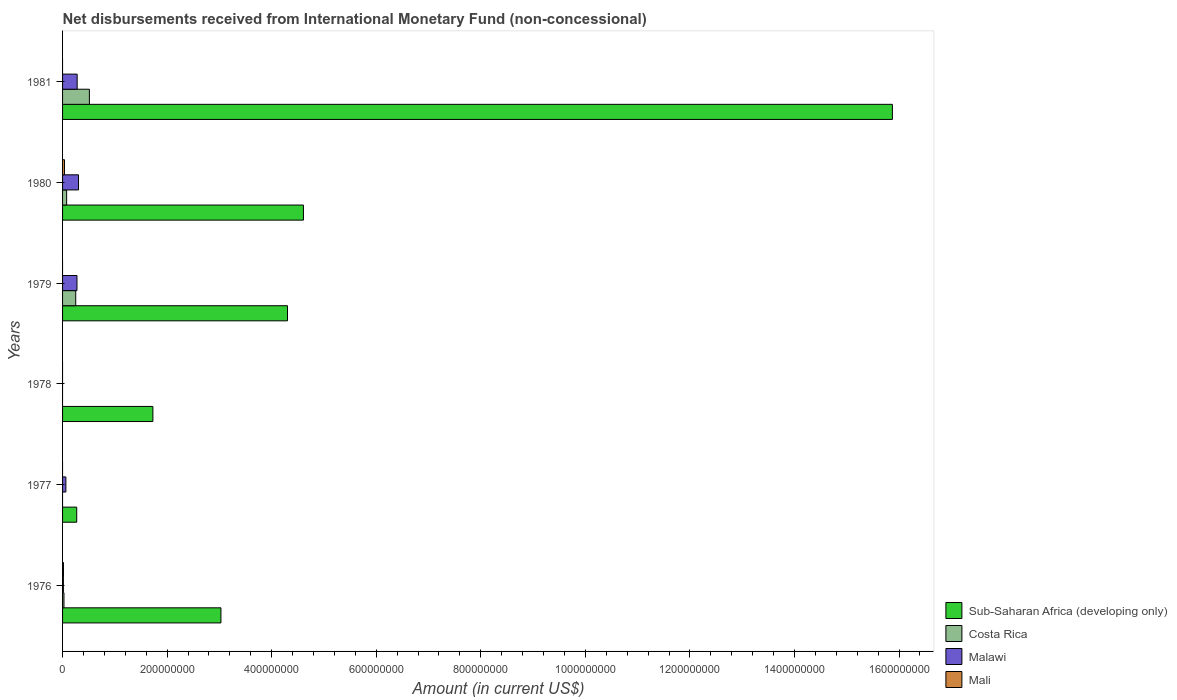How many different coloured bars are there?
Your answer should be very brief. 4. Are the number of bars per tick equal to the number of legend labels?
Offer a terse response. No. What is the label of the 5th group of bars from the top?
Make the answer very short. 1977. In how many cases, is the number of bars for a given year not equal to the number of legend labels?
Your answer should be compact. 4. Across all years, what is the maximum amount of disbursements received from International Monetary Fund in Malawi?
Provide a succinct answer. 3.05e+07. In which year was the amount of disbursements received from International Monetary Fund in Sub-Saharan Africa (developing only) maximum?
Make the answer very short. 1981. What is the total amount of disbursements received from International Monetary Fund in Costa Rica in the graph?
Keep it short and to the point. 8.70e+07. What is the difference between the amount of disbursements received from International Monetary Fund in Costa Rica in 1979 and that in 1981?
Make the answer very short. -2.61e+07. What is the difference between the amount of disbursements received from International Monetary Fund in Mali in 1980 and the amount of disbursements received from International Monetary Fund in Sub-Saharan Africa (developing only) in 1979?
Provide a succinct answer. -4.27e+08. What is the average amount of disbursements received from International Monetary Fund in Costa Rica per year?
Give a very brief answer. 1.45e+07. In the year 1980, what is the difference between the amount of disbursements received from International Monetary Fund in Malawi and amount of disbursements received from International Monetary Fund in Costa Rica?
Your response must be concise. 2.27e+07. In how many years, is the amount of disbursements received from International Monetary Fund in Costa Rica greater than 120000000 US$?
Provide a succinct answer. 0. What is the ratio of the amount of disbursements received from International Monetary Fund in Malawi in 1977 to that in 1981?
Your answer should be compact. 0.23. Is the amount of disbursements received from International Monetary Fund in Costa Rica in 1976 less than that in 1980?
Provide a short and direct response. Yes. What is the difference between the highest and the second highest amount of disbursements received from International Monetary Fund in Malawi?
Keep it short and to the point. 2.60e+06. What is the difference between the highest and the lowest amount of disbursements received from International Monetary Fund in Sub-Saharan Africa (developing only)?
Your response must be concise. 1.56e+09. Is the sum of the amount of disbursements received from International Monetary Fund in Costa Rica in 1976 and 1981 greater than the maximum amount of disbursements received from International Monetary Fund in Mali across all years?
Keep it short and to the point. Yes. Are all the bars in the graph horizontal?
Your answer should be very brief. Yes. How many years are there in the graph?
Provide a short and direct response. 6. Does the graph contain grids?
Ensure brevity in your answer.  No. Where does the legend appear in the graph?
Your response must be concise. Bottom right. How many legend labels are there?
Offer a very short reply. 4. What is the title of the graph?
Make the answer very short. Net disbursements received from International Monetary Fund (non-concessional). What is the Amount (in current US$) in Sub-Saharan Africa (developing only) in 1976?
Offer a very short reply. 3.03e+08. What is the Amount (in current US$) in Costa Rica in 1976?
Offer a very short reply. 2.69e+06. What is the Amount (in current US$) in Malawi in 1976?
Offer a very short reply. 1.57e+06. What is the Amount (in current US$) of Mali in 1976?
Offer a terse response. 1.72e+06. What is the Amount (in current US$) of Sub-Saharan Africa (developing only) in 1977?
Your answer should be compact. 2.71e+07. What is the Amount (in current US$) of Malawi in 1977?
Your answer should be very brief. 6.34e+06. What is the Amount (in current US$) of Mali in 1977?
Provide a short and direct response. 0. What is the Amount (in current US$) of Sub-Saharan Africa (developing only) in 1978?
Provide a short and direct response. 1.73e+08. What is the Amount (in current US$) in Malawi in 1978?
Your answer should be compact. 0. What is the Amount (in current US$) in Mali in 1978?
Make the answer very short. 0. What is the Amount (in current US$) in Sub-Saharan Africa (developing only) in 1979?
Offer a very short reply. 4.30e+08. What is the Amount (in current US$) of Costa Rica in 1979?
Offer a terse response. 2.52e+07. What is the Amount (in current US$) in Malawi in 1979?
Your response must be concise. 2.75e+07. What is the Amount (in current US$) in Mali in 1979?
Your answer should be compact. 0. What is the Amount (in current US$) in Sub-Saharan Africa (developing only) in 1980?
Offer a terse response. 4.61e+08. What is the Amount (in current US$) of Costa Rica in 1980?
Ensure brevity in your answer.  7.80e+06. What is the Amount (in current US$) in Malawi in 1980?
Make the answer very short. 3.05e+07. What is the Amount (in current US$) of Mali in 1980?
Your response must be concise. 3.70e+06. What is the Amount (in current US$) of Sub-Saharan Africa (developing only) in 1981?
Provide a succinct answer. 1.59e+09. What is the Amount (in current US$) in Costa Rica in 1981?
Offer a terse response. 5.13e+07. What is the Amount (in current US$) of Malawi in 1981?
Give a very brief answer. 2.79e+07. Across all years, what is the maximum Amount (in current US$) in Sub-Saharan Africa (developing only)?
Offer a terse response. 1.59e+09. Across all years, what is the maximum Amount (in current US$) in Costa Rica?
Give a very brief answer. 5.13e+07. Across all years, what is the maximum Amount (in current US$) of Malawi?
Give a very brief answer. 3.05e+07. Across all years, what is the maximum Amount (in current US$) in Mali?
Offer a terse response. 3.70e+06. Across all years, what is the minimum Amount (in current US$) in Sub-Saharan Africa (developing only)?
Ensure brevity in your answer.  2.71e+07. Across all years, what is the minimum Amount (in current US$) in Costa Rica?
Your answer should be compact. 0. What is the total Amount (in current US$) of Sub-Saharan Africa (developing only) in the graph?
Give a very brief answer. 2.98e+09. What is the total Amount (in current US$) of Costa Rica in the graph?
Your answer should be very brief. 8.70e+07. What is the total Amount (in current US$) of Malawi in the graph?
Provide a succinct answer. 9.38e+07. What is the total Amount (in current US$) in Mali in the graph?
Offer a terse response. 5.42e+06. What is the difference between the Amount (in current US$) in Sub-Saharan Africa (developing only) in 1976 and that in 1977?
Make the answer very short. 2.76e+08. What is the difference between the Amount (in current US$) in Malawi in 1976 and that in 1977?
Offer a very short reply. -4.77e+06. What is the difference between the Amount (in current US$) in Sub-Saharan Africa (developing only) in 1976 and that in 1978?
Your answer should be compact. 1.30e+08. What is the difference between the Amount (in current US$) in Sub-Saharan Africa (developing only) in 1976 and that in 1979?
Keep it short and to the point. -1.27e+08. What is the difference between the Amount (in current US$) of Costa Rica in 1976 and that in 1979?
Your response must be concise. -2.25e+07. What is the difference between the Amount (in current US$) of Malawi in 1976 and that in 1979?
Ensure brevity in your answer.  -2.60e+07. What is the difference between the Amount (in current US$) of Sub-Saharan Africa (developing only) in 1976 and that in 1980?
Provide a succinct answer. -1.58e+08. What is the difference between the Amount (in current US$) in Costa Rica in 1976 and that in 1980?
Make the answer very short. -5.11e+06. What is the difference between the Amount (in current US$) in Malawi in 1976 and that in 1980?
Keep it short and to the point. -2.89e+07. What is the difference between the Amount (in current US$) in Mali in 1976 and that in 1980?
Keep it short and to the point. -1.98e+06. What is the difference between the Amount (in current US$) in Sub-Saharan Africa (developing only) in 1976 and that in 1981?
Your answer should be very brief. -1.28e+09. What is the difference between the Amount (in current US$) in Costa Rica in 1976 and that in 1981?
Provide a short and direct response. -4.86e+07. What is the difference between the Amount (in current US$) of Malawi in 1976 and that in 1981?
Your answer should be compact. -2.63e+07. What is the difference between the Amount (in current US$) of Sub-Saharan Africa (developing only) in 1977 and that in 1978?
Your answer should be compact. -1.46e+08. What is the difference between the Amount (in current US$) in Sub-Saharan Africa (developing only) in 1977 and that in 1979?
Offer a terse response. -4.03e+08. What is the difference between the Amount (in current US$) of Malawi in 1977 and that in 1979?
Provide a short and direct response. -2.12e+07. What is the difference between the Amount (in current US$) of Sub-Saharan Africa (developing only) in 1977 and that in 1980?
Your response must be concise. -4.34e+08. What is the difference between the Amount (in current US$) of Malawi in 1977 and that in 1980?
Your response must be concise. -2.42e+07. What is the difference between the Amount (in current US$) of Sub-Saharan Africa (developing only) in 1977 and that in 1981?
Keep it short and to the point. -1.56e+09. What is the difference between the Amount (in current US$) of Malawi in 1977 and that in 1981?
Offer a terse response. -2.16e+07. What is the difference between the Amount (in current US$) of Sub-Saharan Africa (developing only) in 1978 and that in 1979?
Your answer should be compact. -2.57e+08. What is the difference between the Amount (in current US$) of Sub-Saharan Africa (developing only) in 1978 and that in 1980?
Keep it short and to the point. -2.88e+08. What is the difference between the Amount (in current US$) of Sub-Saharan Africa (developing only) in 1978 and that in 1981?
Ensure brevity in your answer.  -1.41e+09. What is the difference between the Amount (in current US$) of Sub-Saharan Africa (developing only) in 1979 and that in 1980?
Ensure brevity in your answer.  -3.05e+07. What is the difference between the Amount (in current US$) in Costa Rica in 1979 and that in 1980?
Provide a succinct answer. 1.74e+07. What is the difference between the Amount (in current US$) of Malawi in 1979 and that in 1980?
Keep it short and to the point. -2.97e+06. What is the difference between the Amount (in current US$) of Sub-Saharan Africa (developing only) in 1979 and that in 1981?
Your response must be concise. -1.16e+09. What is the difference between the Amount (in current US$) in Costa Rica in 1979 and that in 1981?
Provide a succinct answer. -2.61e+07. What is the difference between the Amount (in current US$) of Malawi in 1979 and that in 1981?
Your answer should be very brief. -3.66e+05. What is the difference between the Amount (in current US$) of Sub-Saharan Africa (developing only) in 1980 and that in 1981?
Your answer should be very brief. -1.13e+09. What is the difference between the Amount (in current US$) in Costa Rica in 1980 and that in 1981?
Your answer should be compact. -4.35e+07. What is the difference between the Amount (in current US$) of Malawi in 1980 and that in 1981?
Keep it short and to the point. 2.60e+06. What is the difference between the Amount (in current US$) of Sub-Saharan Africa (developing only) in 1976 and the Amount (in current US$) of Malawi in 1977?
Your response must be concise. 2.97e+08. What is the difference between the Amount (in current US$) in Costa Rica in 1976 and the Amount (in current US$) in Malawi in 1977?
Your answer should be compact. -3.65e+06. What is the difference between the Amount (in current US$) of Sub-Saharan Africa (developing only) in 1976 and the Amount (in current US$) of Costa Rica in 1979?
Give a very brief answer. 2.78e+08. What is the difference between the Amount (in current US$) of Sub-Saharan Africa (developing only) in 1976 and the Amount (in current US$) of Malawi in 1979?
Provide a succinct answer. 2.75e+08. What is the difference between the Amount (in current US$) in Costa Rica in 1976 and the Amount (in current US$) in Malawi in 1979?
Give a very brief answer. -2.48e+07. What is the difference between the Amount (in current US$) in Sub-Saharan Africa (developing only) in 1976 and the Amount (in current US$) in Costa Rica in 1980?
Make the answer very short. 2.95e+08. What is the difference between the Amount (in current US$) in Sub-Saharan Africa (developing only) in 1976 and the Amount (in current US$) in Malawi in 1980?
Ensure brevity in your answer.  2.72e+08. What is the difference between the Amount (in current US$) of Sub-Saharan Africa (developing only) in 1976 and the Amount (in current US$) of Mali in 1980?
Keep it short and to the point. 2.99e+08. What is the difference between the Amount (in current US$) in Costa Rica in 1976 and the Amount (in current US$) in Malawi in 1980?
Your answer should be very brief. -2.78e+07. What is the difference between the Amount (in current US$) in Costa Rica in 1976 and the Amount (in current US$) in Mali in 1980?
Ensure brevity in your answer.  -1.01e+06. What is the difference between the Amount (in current US$) in Malawi in 1976 and the Amount (in current US$) in Mali in 1980?
Provide a short and direct response. -2.13e+06. What is the difference between the Amount (in current US$) in Sub-Saharan Africa (developing only) in 1976 and the Amount (in current US$) in Costa Rica in 1981?
Provide a short and direct response. 2.52e+08. What is the difference between the Amount (in current US$) of Sub-Saharan Africa (developing only) in 1976 and the Amount (in current US$) of Malawi in 1981?
Make the answer very short. 2.75e+08. What is the difference between the Amount (in current US$) of Costa Rica in 1976 and the Amount (in current US$) of Malawi in 1981?
Keep it short and to the point. -2.52e+07. What is the difference between the Amount (in current US$) in Sub-Saharan Africa (developing only) in 1977 and the Amount (in current US$) in Costa Rica in 1979?
Give a very brief answer. 1.89e+06. What is the difference between the Amount (in current US$) of Sub-Saharan Africa (developing only) in 1977 and the Amount (in current US$) of Malawi in 1979?
Offer a very short reply. -4.60e+05. What is the difference between the Amount (in current US$) of Sub-Saharan Africa (developing only) in 1977 and the Amount (in current US$) of Costa Rica in 1980?
Offer a very short reply. 1.93e+07. What is the difference between the Amount (in current US$) of Sub-Saharan Africa (developing only) in 1977 and the Amount (in current US$) of Malawi in 1980?
Give a very brief answer. -3.43e+06. What is the difference between the Amount (in current US$) of Sub-Saharan Africa (developing only) in 1977 and the Amount (in current US$) of Mali in 1980?
Provide a short and direct response. 2.34e+07. What is the difference between the Amount (in current US$) of Malawi in 1977 and the Amount (in current US$) of Mali in 1980?
Your answer should be very brief. 2.64e+06. What is the difference between the Amount (in current US$) of Sub-Saharan Africa (developing only) in 1977 and the Amount (in current US$) of Costa Rica in 1981?
Your answer should be compact. -2.42e+07. What is the difference between the Amount (in current US$) in Sub-Saharan Africa (developing only) in 1977 and the Amount (in current US$) in Malawi in 1981?
Ensure brevity in your answer.  -8.26e+05. What is the difference between the Amount (in current US$) of Sub-Saharan Africa (developing only) in 1978 and the Amount (in current US$) of Costa Rica in 1979?
Your answer should be very brief. 1.48e+08. What is the difference between the Amount (in current US$) of Sub-Saharan Africa (developing only) in 1978 and the Amount (in current US$) of Malawi in 1979?
Offer a terse response. 1.45e+08. What is the difference between the Amount (in current US$) in Sub-Saharan Africa (developing only) in 1978 and the Amount (in current US$) in Costa Rica in 1980?
Ensure brevity in your answer.  1.65e+08. What is the difference between the Amount (in current US$) in Sub-Saharan Africa (developing only) in 1978 and the Amount (in current US$) in Malawi in 1980?
Offer a very short reply. 1.42e+08. What is the difference between the Amount (in current US$) in Sub-Saharan Africa (developing only) in 1978 and the Amount (in current US$) in Mali in 1980?
Your response must be concise. 1.69e+08. What is the difference between the Amount (in current US$) of Sub-Saharan Africa (developing only) in 1978 and the Amount (in current US$) of Costa Rica in 1981?
Provide a short and direct response. 1.21e+08. What is the difference between the Amount (in current US$) of Sub-Saharan Africa (developing only) in 1978 and the Amount (in current US$) of Malawi in 1981?
Make the answer very short. 1.45e+08. What is the difference between the Amount (in current US$) in Sub-Saharan Africa (developing only) in 1979 and the Amount (in current US$) in Costa Rica in 1980?
Your answer should be compact. 4.22e+08. What is the difference between the Amount (in current US$) in Sub-Saharan Africa (developing only) in 1979 and the Amount (in current US$) in Malawi in 1980?
Make the answer very short. 4.00e+08. What is the difference between the Amount (in current US$) in Sub-Saharan Africa (developing only) in 1979 and the Amount (in current US$) in Mali in 1980?
Offer a terse response. 4.27e+08. What is the difference between the Amount (in current US$) of Costa Rica in 1979 and the Amount (in current US$) of Malawi in 1980?
Make the answer very short. -5.32e+06. What is the difference between the Amount (in current US$) of Costa Rica in 1979 and the Amount (in current US$) of Mali in 1980?
Keep it short and to the point. 2.15e+07. What is the difference between the Amount (in current US$) of Malawi in 1979 and the Amount (in current US$) of Mali in 1980?
Offer a terse response. 2.38e+07. What is the difference between the Amount (in current US$) in Sub-Saharan Africa (developing only) in 1979 and the Amount (in current US$) in Costa Rica in 1981?
Your answer should be compact. 3.79e+08. What is the difference between the Amount (in current US$) of Sub-Saharan Africa (developing only) in 1979 and the Amount (in current US$) of Malawi in 1981?
Offer a terse response. 4.02e+08. What is the difference between the Amount (in current US$) in Costa Rica in 1979 and the Amount (in current US$) in Malawi in 1981?
Offer a terse response. -2.72e+06. What is the difference between the Amount (in current US$) of Sub-Saharan Africa (developing only) in 1980 and the Amount (in current US$) of Costa Rica in 1981?
Ensure brevity in your answer.  4.09e+08. What is the difference between the Amount (in current US$) of Sub-Saharan Africa (developing only) in 1980 and the Amount (in current US$) of Malawi in 1981?
Provide a short and direct response. 4.33e+08. What is the difference between the Amount (in current US$) of Costa Rica in 1980 and the Amount (in current US$) of Malawi in 1981?
Offer a terse response. -2.01e+07. What is the average Amount (in current US$) in Sub-Saharan Africa (developing only) per year?
Keep it short and to the point. 4.97e+08. What is the average Amount (in current US$) in Costa Rica per year?
Keep it short and to the point. 1.45e+07. What is the average Amount (in current US$) in Malawi per year?
Your response must be concise. 1.56e+07. What is the average Amount (in current US$) in Mali per year?
Your response must be concise. 9.04e+05. In the year 1976, what is the difference between the Amount (in current US$) of Sub-Saharan Africa (developing only) and Amount (in current US$) of Costa Rica?
Provide a short and direct response. 3.00e+08. In the year 1976, what is the difference between the Amount (in current US$) in Sub-Saharan Africa (developing only) and Amount (in current US$) in Malawi?
Your response must be concise. 3.01e+08. In the year 1976, what is the difference between the Amount (in current US$) of Sub-Saharan Africa (developing only) and Amount (in current US$) of Mali?
Your answer should be compact. 3.01e+08. In the year 1976, what is the difference between the Amount (in current US$) of Costa Rica and Amount (in current US$) of Malawi?
Offer a terse response. 1.12e+06. In the year 1976, what is the difference between the Amount (in current US$) of Costa Rica and Amount (in current US$) of Mali?
Offer a terse response. 9.70e+05. In the year 1976, what is the difference between the Amount (in current US$) in Malawi and Amount (in current US$) in Mali?
Ensure brevity in your answer.  -1.51e+05. In the year 1977, what is the difference between the Amount (in current US$) in Sub-Saharan Africa (developing only) and Amount (in current US$) in Malawi?
Make the answer very short. 2.07e+07. In the year 1979, what is the difference between the Amount (in current US$) of Sub-Saharan Africa (developing only) and Amount (in current US$) of Costa Rica?
Ensure brevity in your answer.  4.05e+08. In the year 1979, what is the difference between the Amount (in current US$) in Sub-Saharan Africa (developing only) and Amount (in current US$) in Malawi?
Provide a short and direct response. 4.03e+08. In the year 1979, what is the difference between the Amount (in current US$) in Costa Rica and Amount (in current US$) in Malawi?
Your answer should be very brief. -2.35e+06. In the year 1980, what is the difference between the Amount (in current US$) in Sub-Saharan Africa (developing only) and Amount (in current US$) in Costa Rica?
Your answer should be very brief. 4.53e+08. In the year 1980, what is the difference between the Amount (in current US$) of Sub-Saharan Africa (developing only) and Amount (in current US$) of Malawi?
Your response must be concise. 4.30e+08. In the year 1980, what is the difference between the Amount (in current US$) in Sub-Saharan Africa (developing only) and Amount (in current US$) in Mali?
Your response must be concise. 4.57e+08. In the year 1980, what is the difference between the Amount (in current US$) of Costa Rica and Amount (in current US$) of Malawi?
Your response must be concise. -2.27e+07. In the year 1980, what is the difference between the Amount (in current US$) in Costa Rica and Amount (in current US$) in Mali?
Keep it short and to the point. 4.10e+06. In the year 1980, what is the difference between the Amount (in current US$) in Malawi and Amount (in current US$) in Mali?
Offer a very short reply. 2.68e+07. In the year 1981, what is the difference between the Amount (in current US$) in Sub-Saharan Africa (developing only) and Amount (in current US$) in Costa Rica?
Provide a succinct answer. 1.54e+09. In the year 1981, what is the difference between the Amount (in current US$) of Sub-Saharan Africa (developing only) and Amount (in current US$) of Malawi?
Give a very brief answer. 1.56e+09. In the year 1981, what is the difference between the Amount (in current US$) of Costa Rica and Amount (in current US$) of Malawi?
Make the answer very short. 2.34e+07. What is the ratio of the Amount (in current US$) in Sub-Saharan Africa (developing only) in 1976 to that in 1977?
Make the answer very short. 11.19. What is the ratio of the Amount (in current US$) in Malawi in 1976 to that in 1977?
Provide a short and direct response. 0.25. What is the ratio of the Amount (in current US$) of Sub-Saharan Africa (developing only) in 1976 to that in 1978?
Offer a terse response. 1.75. What is the ratio of the Amount (in current US$) of Sub-Saharan Africa (developing only) in 1976 to that in 1979?
Provide a succinct answer. 0.7. What is the ratio of the Amount (in current US$) in Costa Rica in 1976 to that in 1979?
Your response must be concise. 0.11. What is the ratio of the Amount (in current US$) of Malawi in 1976 to that in 1979?
Offer a terse response. 0.06. What is the ratio of the Amount (in current US$) in Sub-Saharan Africa (developing only) in 1976 to that in 1980?
Offer a terse response. 0.66. What is the ratio of the Amount (in current US$) in Costa Rica in 1976 to that in 1980?
Offer a very short reply. 0.34. What is the ratio of the Amount (in current US$) of Malawi in 1976 to that in 1980?
Ensure brevity in your answer.  0.05. What is the ratio of the Amount (in current US$) of Mali in 1976 to that in 1980?
Your answer should be compact. 0.47. What is the ratio of the Amount (in current US$) in Sub-Saharan Africa (developing only) in 1976 to that in 1981?
Your response must be concise. 0.19. What is the ratio of the Amount (in current US$) in Costa Rica in 1976 to that in 1981?
Offer a very short reply. 0.05. What is the ratio of the Amount (in current US$) of Malawi in 1976 to that in 1981?
Provide a short and direct response. 0.06. What is the ratio of the Amount (in current US$) in Sub-Saharan Africa (developing only) in 1977 to that in 1978?
Offer a very short reply. 0.16. What is the ratio of the Amount (in current US$) in Sub-Saharan Africa (developing only) in 1977 to that in 1979?
Give a very brief answer. 0.06. What is the ratio of the Amount (in current US$) of Malawi in 1977 to that in 1979?
Give a very brief answer. 0.23. What is the ratio of the Amount (in current US$) in Sub-Saharan Africa (developing only) in 1977 to that in 1980?
Offer a terse response. 0.06. What is the ratio of the Amount (in current US$) of Malawi in 1977 to that in 1980?
Offer a terse response. 0.21. What is the ratio of the Amount (in current US$) of Sub-Saharan Africa (developing only) in 1977 to that in 1981?
Provide a succinct answer. 0.02. What is the ratio of the Amount (in current US$) of Malawi in 1977 to that in 1981?
Provide a short and direct response. 0.23. What is the ratio of the Amount (in current US$) in Sub-Saharan Africa (developing only) in 1978 to that in 1979?
Provide a succinct answer. 0.4. What is the ratio of the Amount (in current US$) in Sub-Saharan Africa (developing only) in 1978 to that in 1980?
Offer a terse response. 0.38. What is the ratio of the Amount (in current US$) in Sub-Saharan Africa (developing only) in 1978 to that in 1981?
Your answer should be very brief. 0.11. What is the ratio of the Amount (in current US$) of Sub-Saharan Africa (developing only) in 1979 to that in 1980?
Your answer should be very brief. 0.93. What is the ratio of the Amount (in current US$) in Costa Rica in 1979 to that in 1980?
Ensure brevity in your answer.  3.23. What is the ratio of the Amount (in current US$) in Malawi in 1979 to that in 1980?
Provide a short and direct response. 0.9. What is the ratio of the Amount (in current US$) in Sub-Saharan Africa (developing only) in 1979 to that in 1981?
Provide a short and direct response. 0.27. What is the ratio of the Amount (in current US$) of Costa Rica in 1979 to that in 1981?
Your answer should be compact. 0.49. What is the ratio of the Amount (in current US$) in Malawi in 1979 to that in 1981?
Provide a short and direct response. 0.99. What is the ratio of the Amount (in current US$) of Sub-Saharan Africa (developing only) in 1980 to that in 1981?
Offer a terse response. 0.29. What is the ratio of the Amount (in current US$) in Costa Rica in 1980 to that in 1981?
Your answer should be very brief. 0.15. What is the ratio of the Amount (in current US$) in Malawi in 1980 to that in 1981?
Give a very brief answer. 1.09. What is the difference between the highest and the second highest Amount (in current US$) in Sub-Saharan Africa (developing only)?
Provide a succinct answer. 1.13e+09. What is the difference between the highest and the second highest Amount (in current US$) of Costa Rica?
Your response must be concise. 2.61e+07. What is the difference between the highest and the second highest Amount (in current US$) in Malawi?
Offer a very short reply. 2.60e+06. What is the difference between the highest and the lowest Amount (in current US$) of Sub-Saharan Africa (developing only)?
Your response must be concise. 1.56e+09. What is the difference between the highest and the lowest Amount (in current US$) of Costa Rica?
Make the answer very short. 5.13e+07. What is the difference between the highest and the lowest Amount (in current US$) of Malawi?
Make the answer very short. 3.05e+07. What is the difference between the highest and the lowest Amount (in current US$) of Mali?
Your answer should be very brief. 3.70e+06. 